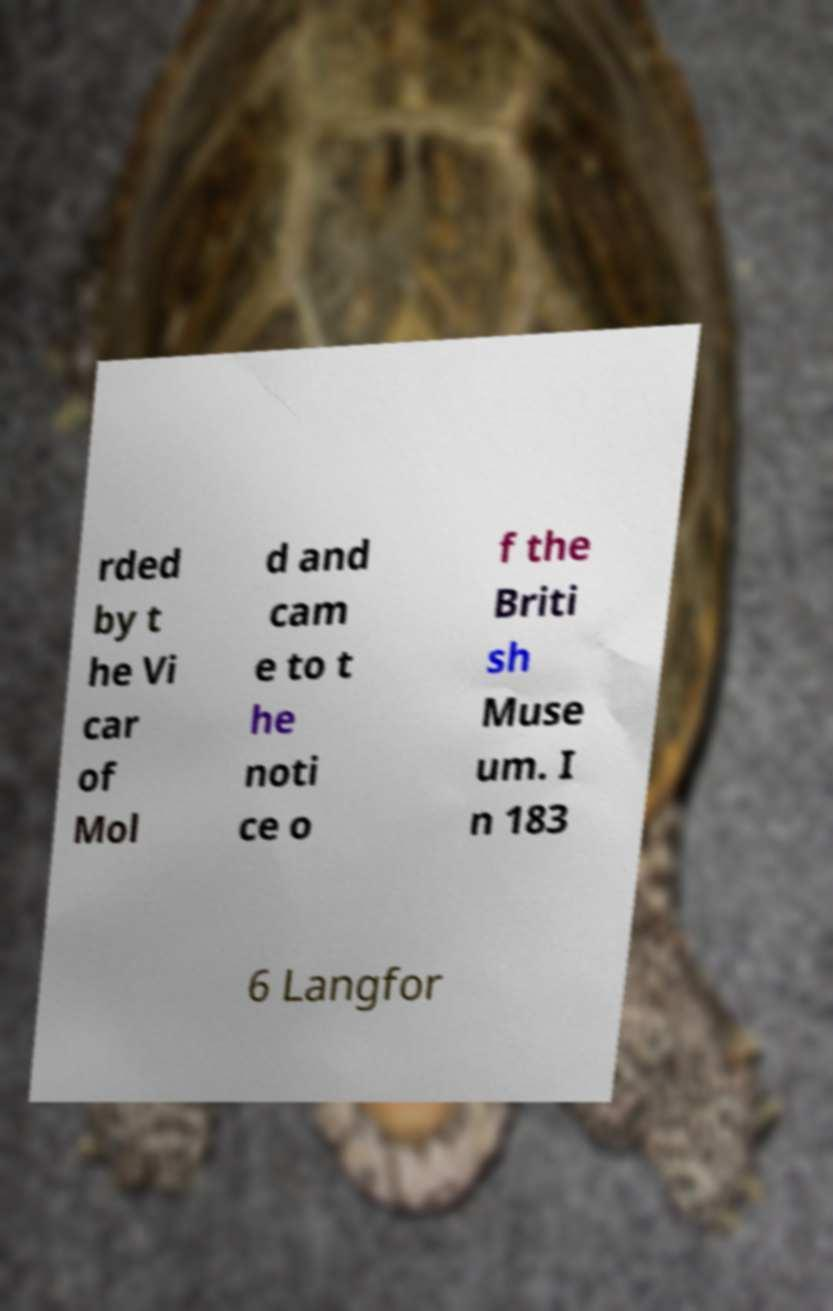There's text embedded in this image that I need extracted. Can you transcribe it verbatim? rded by t he Vi car of Mol d and cam e to t he noti ce o f the Briti sh Muse um. I n 183 6 Langfor 